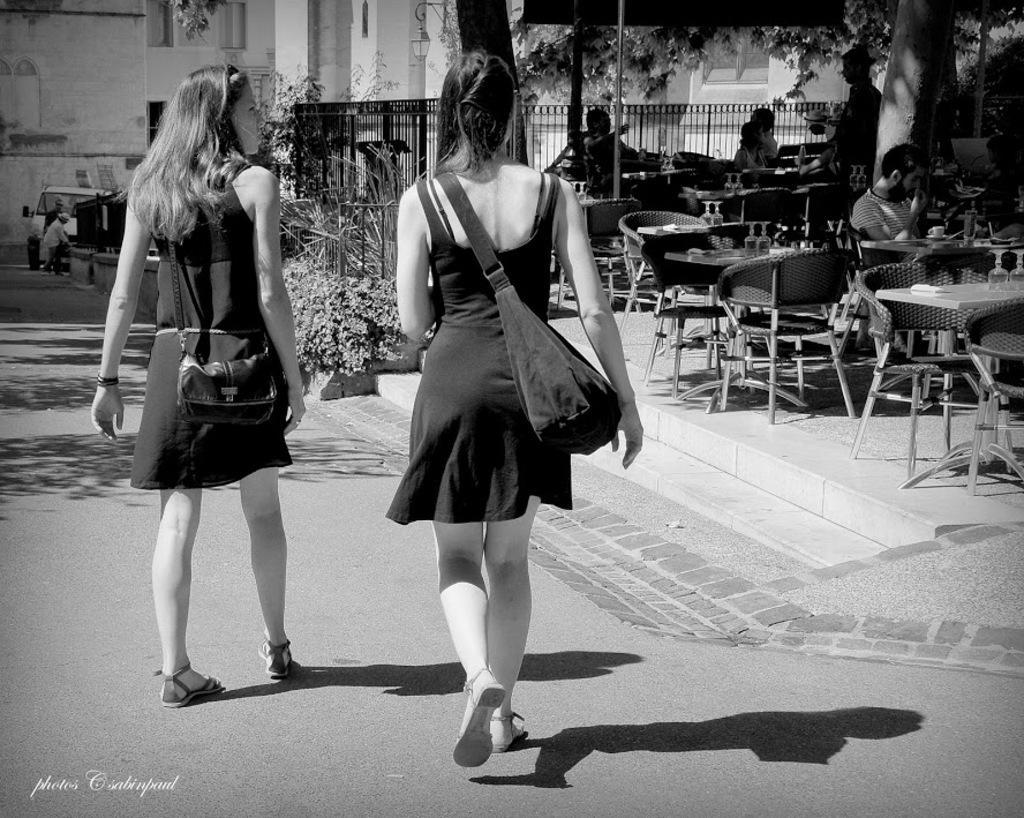Describe this image in one or two sentences. This is a black and white picture. Here we can see two women wearing boots and walking on the road. This is a vehicle. We can see persons sitting on chairs in front of a table and on the table we can see glasses. This is a fence. This is a tree. 